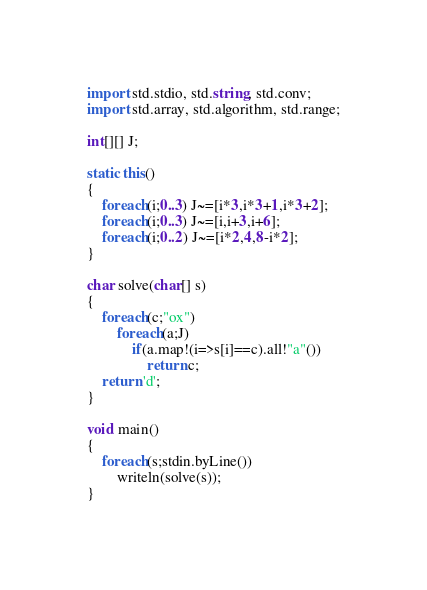<code> <loc_0><loc_0><loc_500><loc_500><_D_>import std.stdio, std.string, std.conv;
import std.array, std.algorithm, std.range;

int[][] J;

static this()
{
    foreach(i;0..3) J~=[i*3,i*3+1,i*3+2];
    foreach(i;0..3) J~=[i,i+3,i+6];
    foreach(i;0..2) J~=[i*2,4,8-i*2];
}

char solve(char[] s)
{
    foreach(c;"ox")
        foreach(a;J)
            if(a.map!(i=>s[i]==c).all!"a"())
                return c;
    return 'd';
}

void main()
{
    foreach(s;stdin.byLine())
        writeln(solve(s));
}</code> 